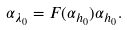Convert formula to latex. <formula><loc_0><loc_0><loc_500><loc_500>\alpha _ { \lambda _ { 0 } } = F ( \alpha _ { h _ { 0 } } ) \alpha _ { h _ { 0 } } .</formula> 